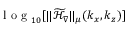<formula> <loc_0><loc_0><loc_500><loc_500>l o g _ { 1 0 } [ \| \mathcal { \widetilde { H } } _ { \nabla } \| _ { \mu } ( k _ { x } , k _ { z } ) ]</formula> 